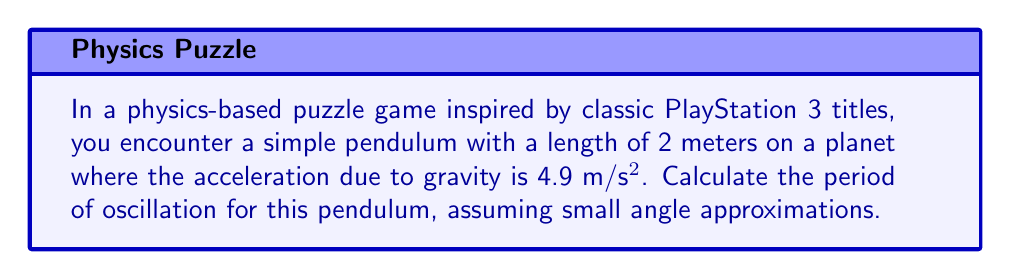Give your solution to this math problem. Let's approach this step-by-step:

1. The formula for the period of a simple pendulum under small angle approximations is:

   $$T = 2\pi\sqrt{\frac{L}{g}}$$

   Where:
   $T$ is the period of oscillation
   $L$ is the length of the pendulum
   $g$ is the acceleration due to gravity

2. We are given:
   $L = 2$ meters
   $g = 4.9$ m/s²

3. Let's substitute these values into our equation:

   $$T = 2\pi\sqrt{\frac{2}{4.9}}$$

4. Simplify inside the square root:

   $$T = 2\pi\sqrt{0.4081632653}$$

5. Calculate the square root:

   $$T = 2\pi \cdot 0.6388656727$$

6. Multiply:

   $$T = 4.013076985$$

7. Round to three decimal places for a reasonable game physics approximation:

   $$T \approx 4.013 \text{ seconds}$$

This result means the pendulum will complete one full swing (back and forth) in approximately 4.013 seconds in the game's physics engine.
Answer: $4.013 \text{ seconds}$ 